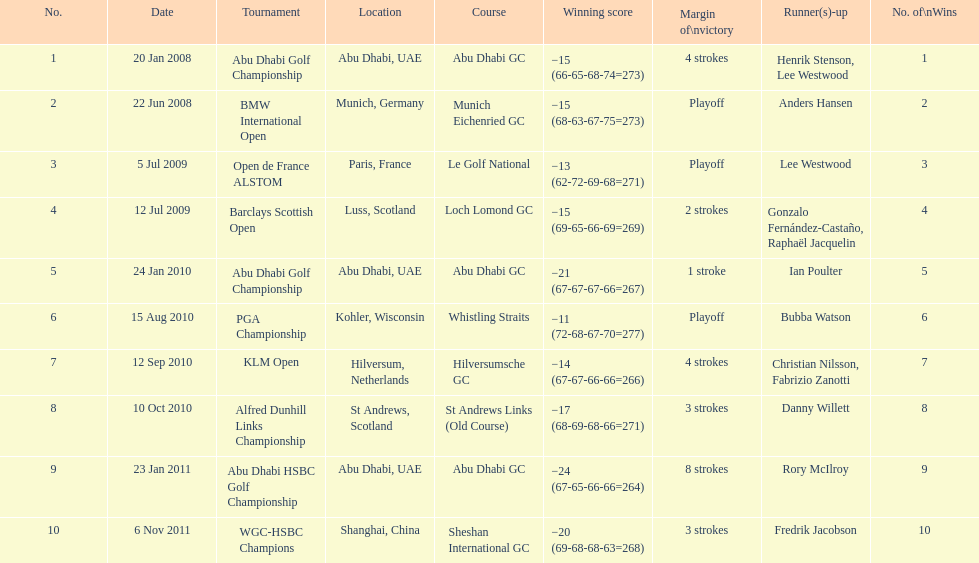How many total tournaments has he won? 10. 